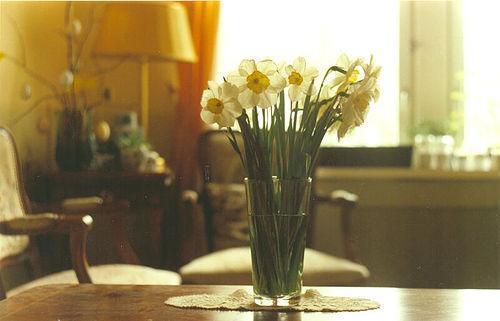How many chairs are depicted?
Give a very brief answer. 2. How many vases are there?
Give a very brief answer. 2. How many chairs can be seen?
Give a very brief answer. 2. How many potted plants are in the picture?
Give a very brief answer. 2. How many bikes are here?
Give a very brief answer. 0. 